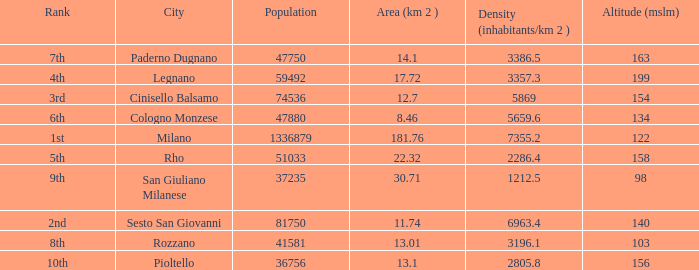Which Population is the highest one that has a Density (inhabitants/km 2) larger than 2805.8, and a Rank of 1st, and an Altitude (mslm) smaller than 122? None. 